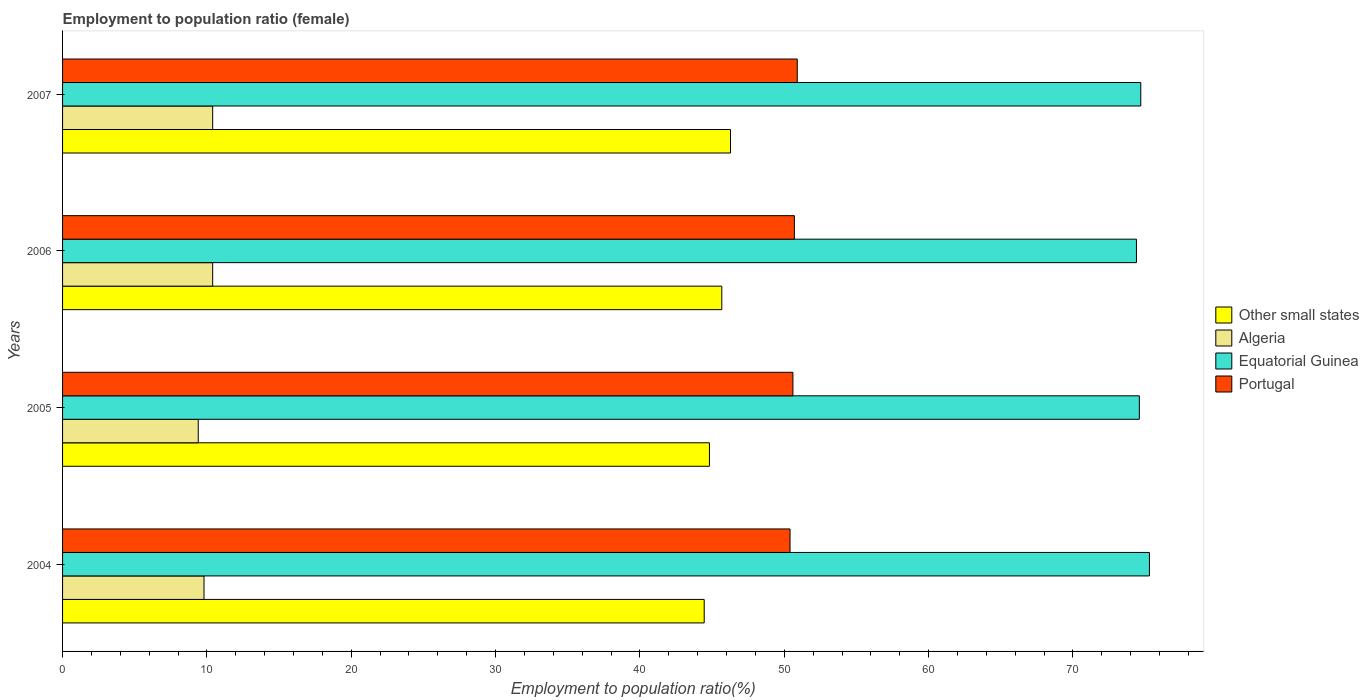How many different coloured bars are there?
Your answer should be compact. 4. How many bars are there on the 1st tick from the top?
Your answer should be compact. 4. How many bars are there on the 1st tick from the bottom?
Provide a short and direct response. 4. What is the label of the 2nd group of bars from the top?
Give a very brief answer. 2006. In how many cases, is the number of bars for a given year not equal to the number of legend labels?
Keep it short and to the point. 0. What is the employment to population ratio in Algeria in 2007?
Offer a very short reply. 10.4. Across all years, what is the maximum employment to population ratio in Other small states?
Ensure brevity in your answer.  46.27. Across all years, what is the minimum employment to population ratio in Other small states?
Make the answer very short. 44.45. In which year was the employment to population ratio in Equatorial Guinea maximum?
Offer a terse response. 2004. What is the total employment to population ratio in Portugal in the graph?
Keep it short and to the point. 202.6. What is the difference between the employment to population ratio in Other small states in 2004 and that in 2005?
Provide a short and direct response. -0.36. What is the difference between the employment to population ratio in Portugal in 2004 and the employment to population ratio in Equatorial Guinea in 2007?
Your answer should be very brief. -24.3. What is the average employment to population ratio in Algeria per year?
Keep it short and to the point. 10. In the year 2005, what is the difference between the employment to population ratio in Portugal and employment to population ratio in Algeria?
Keep it short and to the point. 41.2. What is the ratio of the employment to population ratio in Algeria in 2004 to that in 2006?
Your answer should be very brief. 0.94. Is the employment to population ratio in Equatorial Guinea in 2006 less than that in 2007?
Keep it short and to the point. Yes. What is the difference between the highest and the second highest employment to population ratio in Equatorial Guinea?
Provide a short and direct response. 0.6. What is the difference between the highest and the lowest employment to population ratio in Other small states?
Make the answer very short. 1.82. In how many years, is the employment to population ratio in Portugal greater than the average employment to population ratio in Portugal taken over all years?
Offer a terse response. 2. Is it the case that in every year, the sum of the employment to population ratio in Other small states and employment to population ratio in Equatorial Guinea is greater than the sum of employment to population ratio in Algeria and employment to population ratio in Portugal?
Make the answer very short. Yes. What does the 3rd bar from the top in 2005 represents?
Provide a short and direct response. Algeria. What does the 3rd bar from the bottom in 2006 represents?
Offer a very short reply. Equatorial Guinea. Is it the case that in every year, the sum of the employment to population ratio in Portugal and employment to population ratio in Other small states is greater than the employment to population ratio in Algeria?
Provide a short and direct response. Yes. How many bars are there?
Give a very brief answer. 16. What is the difference between two consecutive major ticks on the X-axis?
Your answer should be compact. 10. Are the values on the major ticks of X-axis written in scientific E-notation?
Offer a terse response. No. Where does the legend appear in the graph?
Keep it short and to the point. Center right. How many legend labels are there?
Offer a terse response. 4. What is the title of the graph?
Your answer should be compact. Employment to population ratio (female). What is the label or title of the X-axis?
Ensure brevity in your answer.  Employment to population ratio(%). What is the Employment to population ratio(%) in Other small states in 2004?
Offer a terse response. 44.45. What is the Employment to population ratio(%) in Algeria in 2004?
Give a very brief answer. 9.8. What is the Employment to population ratio(%) in Equatorial Guinea in 2004?
Provide a short and direct response. 75.3. What is the Employment to population ratio(%) in Portugal in 2004?
Your response must be concise. 50.4. What is the Employment to population ratio(%) of Other small states in 2005?
Your answer should be compact. 44.82. What is the Employment to population ratio(%) of Algeria in 2005?
Your response must be concise. 9.4. What is the Employment to population ratio(%) of Equatorial Guinea in 2005?
Keep it short and to the point. 74.6. What is the Employment to population ratio(%) of Portugal in 2005?
Keep it short and to the point. 50.6. What is the Employment to population ratio(%) in Other small states in 2006?
Your answer should be compact. 45.67. What is the Employment to population ratio(%) of Algeria in 2006?
Provide a succinct answer. 10.4. What is the Employment to population ratio(%) of Equatorial Guinea in 2006?
Provide a short and direct response. 74.4. What is the Employment to population ratio(%) of Portugal in 2006?
Ensure brevity in your answer.  50.7. What is the Employment to population ratio(%) in Other small states in 2007?
Ensure brevity in your answer.  46.27. What is the Employment to population ratio(%) of Algeria in 2007?
Your answer should be very brief. 10.4. What is the Employment to population ratio(%) of Equatorial Guinea in 2007?
Keep it short and to the point. 74.7. What is the Employment to population ratio(%) of Portugal in 2007?
Your answer should be very brief. 50.9. Across all years, what is the maximum Employment to population ratio(%) in Other small states?
Provide a succinct answer. 46.27. Across all years, what is the maximum Employment to population ratio(%) in Algeria?
Offer a terse response. 10.4. Across all years, what is the maximum Employment to population ratio(%) of Equatorial Guinea?
Your answer should be very brief. 75.3. Across all years, what is the maximum Employment to population ratio(%) in Portugal?
Your answer should be very brief. 50.9. Across all years, what is the minimum Employment to population ratio(%) of Other small states?
Your answer should be compact. 44.45. Across all years, what is the minimum Employment to population ratio(%) in Algeria?
Your answer should be compact. 9.4. Across all years, what is the minimum Employment to population ratio(%) of Equatorial Guinea?
Give a very brief answer. 74.4. Across all years, what is the minimum Employment to population ratio(%) of Portugal?
Give a very brief answer. 50.4. What is the total Employment to population ratio(%) in Other small states in the graph?
Ensure brevity in your answer.  181.22. What is the total Employment to population ratio(%) in Equatorial Guinea in the graph?
Offer a terse response. 299. What is the total Employment to population ratio(%) in Portugal in the graph?
Give a very brief answer. 202.6. What is the difference between the Employment to population ratio(%) in Other small states in 2004 and that in 2005?
Your response must be concise. -0.36. What is the difference between the Employment to population ratio(%) of Other small states in 2004 and that in 2006?
Offer a very short reply. -1.22. What is the difference between the Employment to population ratio(%) of Algeria in 2004 and that in 2006?
Provide a succinct answer. -0.6. What is the difference between the Employment to population ratio(%) in Equatorial Guinea in 2004 and that in 2006?
Provide a succinct answer. 0.9. What is the difference between the Employment to population ratio(%) of Portugal in 2004 and that in 2006?
Provide a short and direct response. -0.3. What is the difference between the Employment to population ratio(%) of Other small states in 2004 and that in 2007?
Make the answer very short. -1.82. What is the difference between the Employment to population ratio(%) in Portugal in 2004 and that in 2007?
Provide a succinct answer. -0.5. What is the difference between the Employment to population ratio(%) of Other small states in 2005 and that in 2006?
Provide a short and direct response. -0.85. What is the difference between the Employment to population ratio(%) of Equatorial Guinea in 2005 and that in 2006?
Your answer should be very brief. 0.2. What is the difference between the Employment to population ratio(%) of Portugal in 2005 and that in 2006?
Offer a terse response. -0.1. What is the difference between the Employment to population ratio(%) in Other small states in 2005 and that in 2007?
Give a very brief answer. -1.46. What is the difference between the Employment to population ratio(%) in Algeria in 2005 and that in 2007?
Your response must be concise. -1. What is the difference between the Employment to population ratio(%) of Other small states in 2006 and that in 2007?
Ensure brevity in your answer.  -0.6. What is the difference between the Employment to population ratio(%) of Algeria in 2006 and that in 2007?
Your response must be concise. 0. What is the difference between the Employment to population ratio(%) of Equatorial Guinea in 2006 and that in 2007?
Ensure brevity in your answer.  -0.3. What is the difference between the Employment to population ratio(%) in Other small states in 2004 and the Employment to population ratio(%) in Algeria in 2005?
Ensure brevity in your answer.  35.05. What is the difference between the Employment to population ratio(%) in Other small states in 2004 and the Employment to population ratio(%) in Equatorial Guinea in 2005?
Give a very brief answer. -30.15. What is the difference between the Employment to population ratio(%) in Other small states in 2004 and the Employment to population ratio(%) in Portugal in 2005?
Give a very brief answer. -6.15. What is the difference between the Employment to population ratio(%) of Algeria in 2004 and the Employment to population ratio(%) of Equatorial Guinea in 2005?
Your answer should be compact. -64.8. What is the difference between the Employment to population ratio(%) in Algeria in 2004 and the Employment to population ratio(%) in Portugal in 2005?
Keep it short and to the point. -40.8. What is the difference between the Employment to population ratio(%) of Equatorial Guinea in 2004 and the Employment to population ratio(%) of Portugal in 2005?
Your answer should be very brief. 24.7. What is the difference between the Employment to population ratio(%) in Other small states in 2004 and the Employment to population ratio(%) in Algeria in 2006?
Ensure brevity in your answer.  34.05. What is the difference between the Employment to population ratio(%) of Other small states in 2004 and the Employment to population ratio(%) of Equatorial Guinea in 2006?
Your response must be concise. -29.95. What is the difference between the Employment to population ratio(%) in Other small states in 2004 and the Employment to population ratio(%) in Portugal in 2006?
Provide a succinct answer. -6.25. What is the difference between the Employment to population ratio(%) of Algeria in 2004 and the Employment to population ratio(%) of Equatorial Guinea in 2006?
Provide a short and direct response. -64.6. What is the difference between the Employment to population ratio(%) of Algeria in 2004 and the Employment to population ratio(%) of Portugal in 2006?
Ensure brevity in your answer.  -40.9. What is the difference between the Employment to population ratio(%) in Equatorial Guinea in 2004 and the Employment to population ratio(%) in Portugal in 2006?
Your response must be concise. 24.6. What is the difference between the Employment to population ratio(%) in Other small states in 2004 and the Employment to population ratio(%) in Algeria in 2007?
Ensure brevity in your answer.  34.05. What is the difference between the Employment to population ratio(%) of Other small states in 2004 and the Employment to population ratio(%) of Equatorial Guinea in 2007?
Make the answer very short. -30.25. What is the difference between the Employment to population ratio(%) of Other small states in 2004 and the Employment to population ratio(%) of Portugal in 2007?
Provide a short and direct response. -6.45. What is the difference between the Employment to population ratio(%) in Algeria in 2004 and the Employment to population ratio(%) in Equatorial Guinea in 2007?
Your answer should be compact. -64.9. What is the difference between the Employment to population ratio(%) in Algeria in 2004 and the Employment to population ratio(%) in Portugal in 2007?
Offer a terse response. -41.1. What is the difference between the Employment to population ratio(%) of Equatorial Guinea in 2004 and the Employment to population ratio(%) of Portugal in 2007?
Your answer should be very brief. 24.4. What is the difference between the Employment to population ratio(%) in Other small states in 2005 and the Employment to population ratio(%) in Algeria in 2006?
Offer a very short reply. 34.42. What is the difference between the Employment to population ratio(%) of Other small states in 2005 and the Employment to population ratio(%) of Equatorial Guinea in 2006?
Keep it short and to the point. -29.58. What is the difference between the Employment to population ratio(%) in Other small states in 2005 and the Employment to population ratio(%) in Portugal in 2006?
Make the answer very short. -5.88. What is the difference between the Employment to population ratio(%) in Algeria in 2005 and the Employment to population ratio(%) in Equatorial Guinea in 2006?
Keep it short and to the point. -65. What is the difference between the Employment to population ratio(%) of Algeria in 2005 and the Employment to population ratio(%) of Portugal in 2006?
Your answer should be very brief. -41.3. What is the difference between the Employment to population ratio(%) of Equatorial Guinea in 2005 and the Employment to population ratio(%) of Portugal in 2006?
Give a very brief answer. 23.9. What is the difference between the Employment to population ratio(%) in Other small states in 2005 and the Employment to population ratio(%) in Algeria in 2007?
Make the answer very short. 34.42. What is the difference between the Employment to population ratio(%) in Other small states in 2005 and the Employment to population ratio(%) in Equatorial Guinea in 2007?
Offer a very short reply. -29.88. What is the difference between the Employment to population ratio(%) in Other small states in 2005 and the Employment to population ratio(%) in Portugal in 2007?
Ensure brevity in your answer.  -6.08. What is the difference between the Employment to population ratio(%) of Algeria in 2005 and the Employment to population ratio(%) of Equatorial Guinea in 2007?
Give a very brief answer. -65.3. What is the difference between the Employment to population ratio(%) of Algeria in 2005 and the Employment to population ratio(%) of Portugal in 2007?
Provide a succinct answer. -41.5. What is the difference between the Employment to population ratio(%) of Equatorial Guinea in 2005 and the Employment to population ratio(%) of Portugal in 2007?
Provide a short and direct response. 23.7. What is the difference between the Employment to population ratio(%) in Other small states in 2006 and the Employment to population ratio(%) in Algeria in 2007?
Ensure brevity in your answer.  35.27. What is the difference between the Employment to population ratio(%) in Other small states in 2006 and the Employment to population ratio(%) in Equatorial Guinea in 2007?
Make the answer very short. -29.03. What is the difference between the Employment to population ratio(%) in Other small states in 2006 and the Employment to population ratio(%) in Portugal in 2007?
Offer a very short reply. -5.23. What is the difference between the Employment to population ratio(%) of Algeria in 2006 and the Employment to population ratio(%) of Equatorial Guinea in 2007?
Give a very brief answer. -64.3. What is the difference between the Employment to population ratio(%) in Algeria in 2006 and the Employment to population ratio(%) in Portugal in 2007?
Your response must be concise. -40.5. What is the difference between the Employment to population ratio(%) in Equatorial Guinea in 2006 and the Employment to population ratio(%) in Portugal in 2007?
Offer a very short reply. 23.5. What is the average Employment to population ratio(%) in Other small states per year?
Keep it short and to the point. 45.3. What is the average Employment to population ratio(%) of Equatorial Guinea per year?
Give a very brief answer. 74.75. What is the average Employment to population ratio(%) of Portugal per year?
Your answer should be very brief. 50.65. In the year 2004, what is the difference between the Employment to population ratio(%) of Other small states and Employment to population ratio(%) of Algeria?
Provide a succinct answer. 34.65. In the year 2004, what is the difference between the Employment to population ratio(%) in Other small states and Employment to population ratio(%) in Equatorial Guinea?
Ensure brevity in your answer.  -30.85. In the year 2004, what is the difference between the Employment to population ratio(%) of Other small states and Employment to population ratio(%) of Portugal?
Offer a very short reply. -5.95. In the year 2004, what is the difference between the Employment to population ratio(%) in Algeria and Employment to population ratio(%) in Equatorial Guinea?
Keep it short and to the point. -65.5. In the year 2004, what is the difference between the Employment to population ratio(%) in Algeria and Employment to population ratio(%) in Portugal?
Your answer should be very brief. -40.6. In the year 2004, what is the difference between the Employment to population ratio(%) of Equatorial Guinea and Employment to population ratio(%) of Portugal?
Provide a short and direct response. 24.9. In the year 2005, what is the difference between the Employment to population ratio(%) in Other small states and Employment to population ratio(%) in Algeria?
Offer a very short reply. 35.42. In the year 2005, what is the difference between the Employment to population ratio(%) in Other small states and Employment to population ratio(%) in Equatorial Guinea?
Offer a very short reply. -29.78. In the year 2005, what is the difference between the Employment to population ratio(%) in Other small states and Employment to population ratio(%) in Portugal?
Make the answer very short. -5.78. In the year 2005, what is the difference between the Employment to population ratio(%) in Algeria and Employment to population ratio(%) in Equatorial Guinea?
Provide a short and direct response. -65.2. In the year 2005, what is the difference between the Employment to population ratio(%) in Algeria and Employment to population ratio(%) in Portugal?
Make the answer very short. -41.2. In the year 2005, what is the difference between the Employment to population ratio(%) of Equatorial Guinea and Employment to population ratio(%) of Portugal?
Provide a short and direct response. 24. In the year 2006, what is the difference between the Employment to population ratio(%) of Other small states and Employment to population ratio(%) of Algeria?
Your answer should be very brief. 35.27. In the year 2006, what is the difference between the Employment to population ratio(%) in Other small states and Employment to population ratio(%) in Equatorial Guinea?
Your answer should be compact. -28.73. In the year 2006, what is the difference between the Employment to population ratio(%) of Other small states and Employment to population ratio(%) of Portugal?
Provide a succinct answer. -5.03. In the year 2006, what is the difference between the Employment to population ratio(%) of Algeria and Employment to population ratio(%) of Equatorial Guinea?
Give a very brief answer. -64. In the year 2006, what is the difference between the Employment to population ratio(%) in Algeria and Employment to population ratio(%) in Portugal?
Provide a succinct answer. -40.3. In the year 2006, what is the difference between the Employment to population ratio(%) in Equatorial Guinea and Employment to population ratio(%) in Portugal?
Offer a very short reply. 23.7. In the year 2007, what is the difference between the Employment to population ratio(%) in Other small states and Employment to population ratio(%) in Algeria?
Offer a very short reply. 35.87. In the year 2007, what is the difference between the Employment to population ratio(%) in Other small states and Employment to population ratio(%) in Equatorial Guinea?
Your answer should be compact. -28.43. In the year 2007, what is the difference between the Employment to population ratio(%) in Other small states and Employment to population ratio(%) in Portugal?
Your answer should be very brief. -4.63. In the year 2007, what is the difference between the Employment to population ratio(%) in Algeria and Employment to population ratio(%) in Equatorial Guinea?
Provide a succinct answer. -64.3. In the year 2007, what is the difference between the Employment to population ratio(%) of Algeria and Employment to population ratio(%) of Portugal?
Keep it short and to the point. -40.5. In the year 2007, what is the difference between the Employment to population ratio(%) in Equatorial Guinea and Employment to population ratio(%) in Portugal?
Give a very brief answer. 23.8. What is the ratio of the Employment to population ratio(%) in Other small states in 2004 to that in 2005?
Provide a short and direct response. 0.99. What is the ratio of the Employment to population ratio(%) in Algeria in 2004 to that in 2005?
Keep it short and to the point. 1.04. What is the ratio of the Employment to population ratio(%) of Equatorial Guinea in 2004 to that in 2005?
Ensure brevity in your answer.  1.01. What is the ratio of the Employment to population ratio(%) of Portugal in 2004 to that in 2005?
Provide a short and direct response. 1. What is the ratio of the Employment to population ratio(%) of Other small states in 2004 to that in 2006?
Provide a short and direct response. 0.97. What is the ratio of the Employment to population ratio(%) in Algeria in 2004 to that in 2006?
Your response must be concise. 0.94. What is the ratio of the Employment to population ratio(%) of Equatorial Guinea in 2004 to that in 2006?
Provide a succinct answer. 1.01. What is the ratio of the Employment to population ratio(%) in Other small states in 2004 to that in 2007?
Make the answer very short. 0.96. What is the ratio of the Employment to population ratio(%) of Algeria in 2004 to that in 2007?
Keep it short and to the point. 0.94. What is the ratio of the Employment to population ratio(%) of Portugal in 2004 to that in 2007?
Give a very brief answer. 0.99. What is the ratio of the Employment to population ratio(%) in Other small states in 2005 to that in 2006?
Your answer should be compact. 0.98. What is the ratio of the Employment to population ratio(%) in Algeria in 2005 to that in 2006?
Offer a terse response. 0.9. What is the ratio of the Employment to population ratio(%) of Equatorial Guinea in 2005 to that in 2006?
Give a very brief answer. 1. What is the ratio of the Employment to population ratio(%) in Other small states in 2005 to that in 2007?
Your response must be concise. 0.97. What is the ratio of the Employment to population ratio(%) in Algeria in 2005 to that in 2007?
Your answer should be very brief. 0.9. What is the ratio of the Employment to population ratio(%) in Equatorial Guinea in 2005 to that in 2007?
Keep it short and to the point. 1. What is the ratio of the Employment to population ratio(%) of Other small states in 2006 to that in 2007?
Provide a short and direct response. 0.99. What is the ratio of the Employment to population ratio(%) of Equatorial Guinea in 2006 to that in 2007?
Keep it short and to the point. 1. What is the ratio of the Employment to population ratio(%) in Portugal in 2006 to that in 2007?
Your response must be concise. 1. What is the difference between the highest and the second highest Employment to population ratio(%) in Other small states?
Keep it short and to the point. 0.6. What is the difference between the highest and the lowest Employment to population ratio(%) of Other small states?
Your answer should be very brief. 1.82. What is the difference between the highest and the lowest Employment to population ratio(%) in Algeria?
Your answer should be very brief. 1. What is the difference between the highest and the lowest Employment to population ratio(%) in Portugal?
Keep it short and to the point. 0.5. 